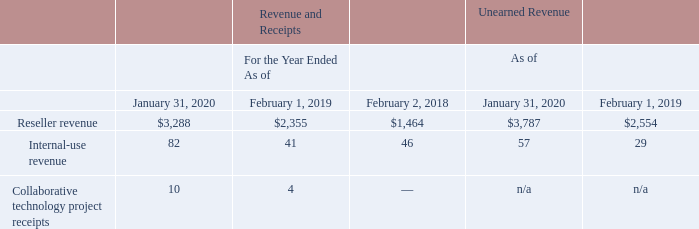Dell purchases our products and services directly from us, as well as through our channel partners. Information about our revenue and receipts, and unearned revenue from such arrangements, for the periods presented consisted of the following (table in millions):
Sales through Dell as a distributor, which is included in reseller revenue, continues to grow rapidly.
Customer deposits resulting from transactions with Dell were $194 million and $85 million as of January 31, 2020 and February 1, 2019, respectively.
What were customer deposits resulting from transactions with Dell in 2020? $194 million. How does Dell purchase products and services from the company? Directly from us, as well as through our channel partners. What was the reseller revenue in 2018?
Answer scale should be: million. 1,464. What was the change in unearned reseller revenue between 2019 and 2020? 
Answer scale should be: million. 3,787-2,554
Answer: 1233. What was the change in Collaborative technology project receipts revenue between 2019 and 2020?
Answer scale should be: million. 10-4
Answer: 6. What was the percentage change in the internal-use revenue between 2019 and 2020?
Answer scale should be: percent. (82-41)/41
Answer: 100. 